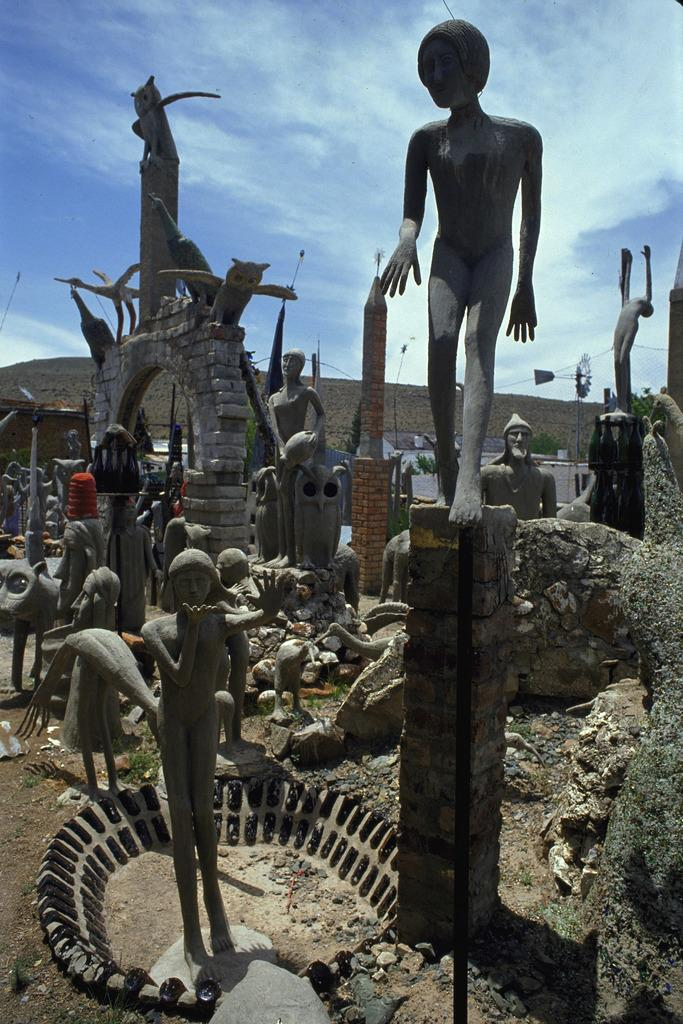What can be seen in the image besides the building in the background? There are statues in the image. What is the color of the sky in the image? The sky is visible in the image, with a combination of white and blue colors. What brand of toothpaste is being advertised on the statues in the image? There is no toothpaste or advertisement present on the statues in the image. What arithmetic problem can be solved using the numbers on the building in the image? There are no numbers visible on the building in the image, so no arithmetic problem can be solved. 